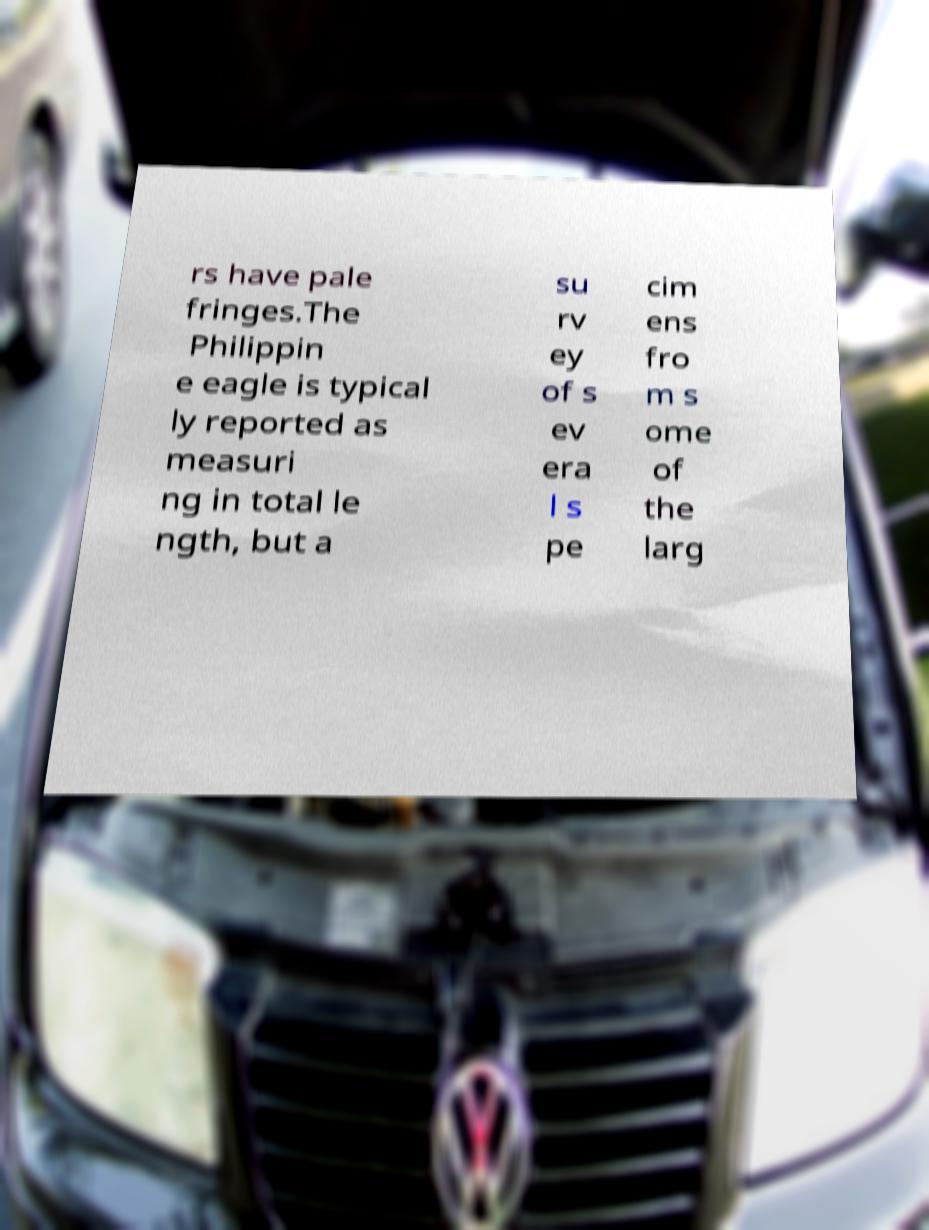There's text embedded in this image that I need extracted. Can you transcribe it verbatim? rs have pale fringes.The Philippin e eagle is typical ly reported as measuri ng in total le ngth, but a su rv ey of s ev era l s pe cim ens fro m s ome of the larg 